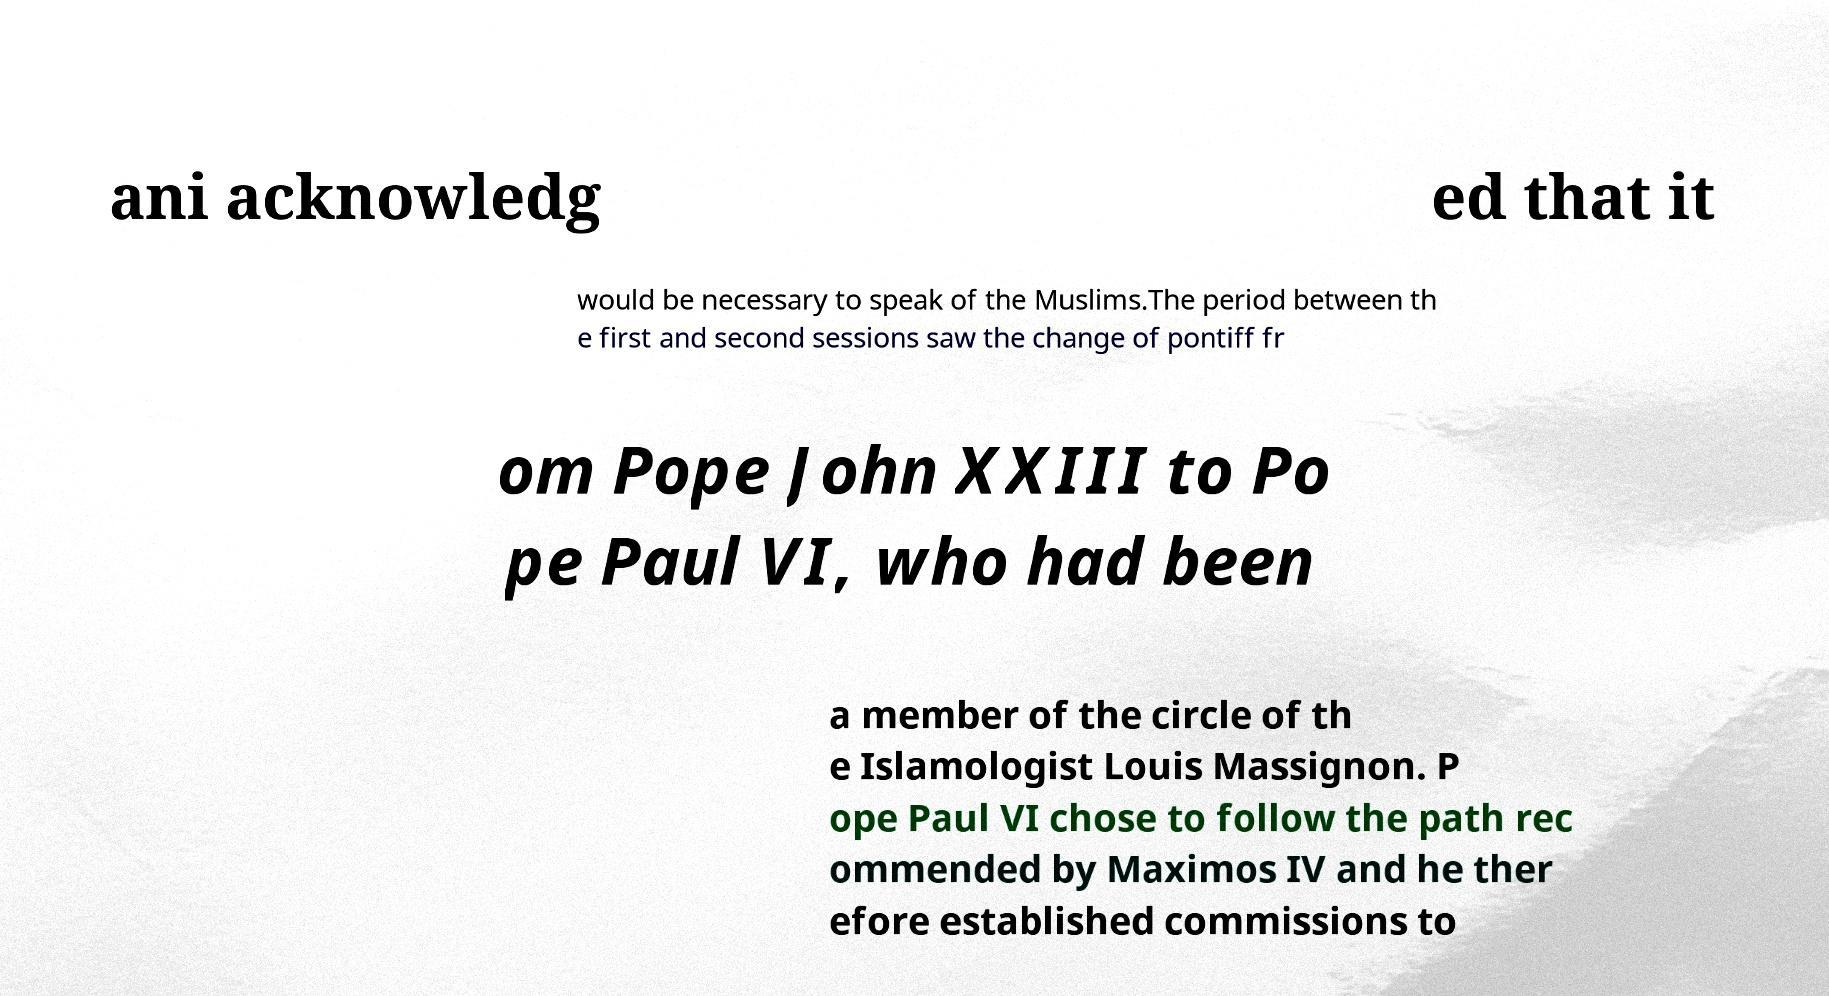I need the written content from this picture converted into text. Can you do that? ani acknowledg ed that it would be necessary to speak of the Muslims.The period between th e first and second sessions saw the change of pontiff fr om Pope John XXIII to Po pe Paul VI, who had been a member of the circle of th e Islamologist Louis Massignon. P ope Paul VI chose to follow the path rec ommended by Maximos IV and he ther efore established commissions to 